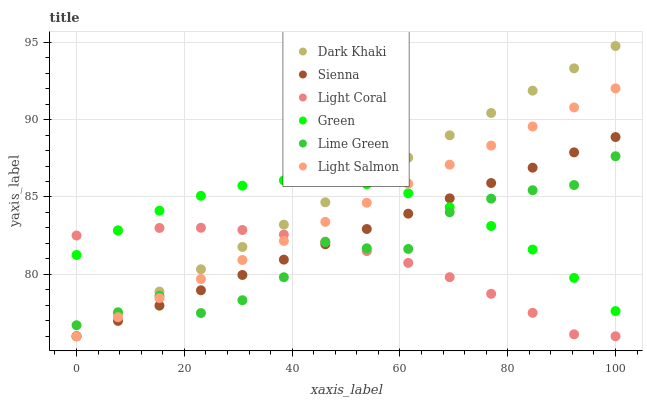Does Light Coral have the minimum area under the curve?
Answer yes or no. Yes. Does Dark Khaki have the maximum area under the curve?
Answer yes or no. Yes. Does Light Salmon have the minimum area under the curve?
Answer yes or no. No. Does Light Salmon have the maximum area under the curve?
Answer yes or no. No. Is Light Salmon the smoothest?
Answer yes or no. Yes. Is Lime Green the roughest?
Answer yes or no. Yes. Is Light Coral the smoothest?
Answer yes or no. No. Is Light Coral the roughest?
Answer yes or no. No. Does Sienna have the lowest value?
Answer yes or no. Yes. Does Green have the lowest value?
Answer yes or no. No. Does Dark Khaki have the highest value?
Answer yes or no. Yes. Does Light Salmon have the highest value?
Answer yes or no. No. Does Lime Green intersect Green?
Answer yes or no. Yes. Is Lime Green less than Green?
Answer yes or no. No. Is Lime Green greater than Green?
Answer yes or no. No. 